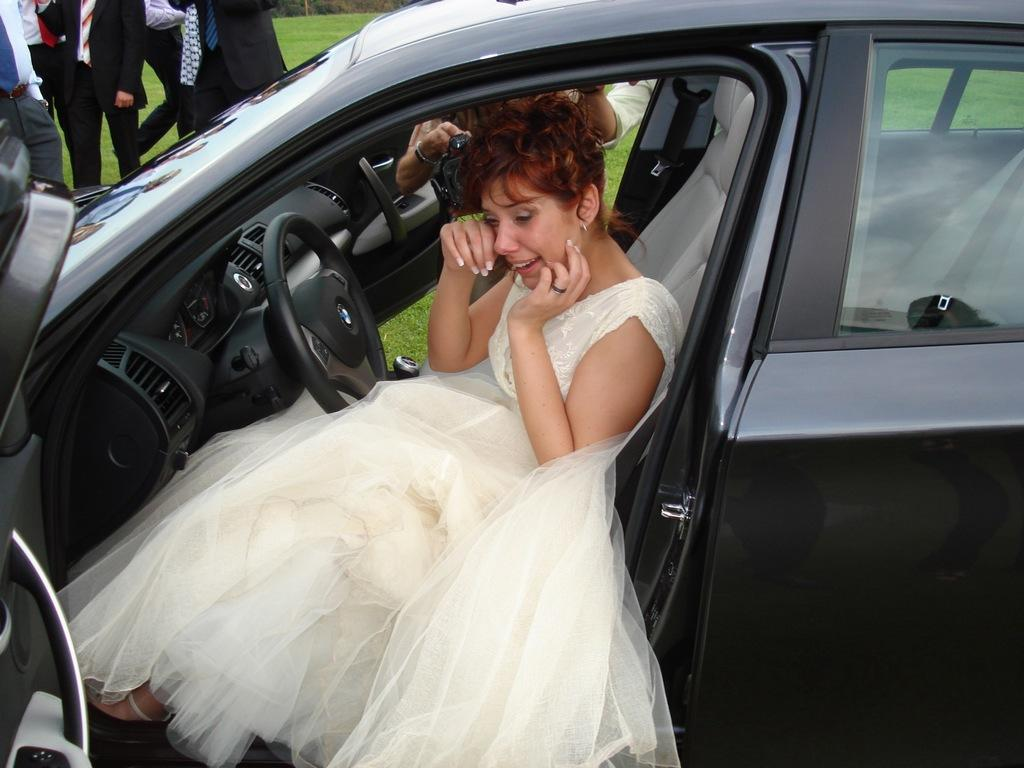What is happening inside the car in the image? There is a woman in the car, and she is crying. What is the woman wearing in the image? The woman is wearing a gown. Where is the car located in the image? The car is in the background of the image. What are the people in the background doing? There are people standing in the background. Who is holding a camera in the image? There is a lady holding a camera. What type of landscape is visible in the image? There is a grass lawn in the image. What type of sponge can be seen on the desk in the image? There is no desk or sponge present in the image. What card game are the people playing in the image? There is no card game or cards visible in the image. 